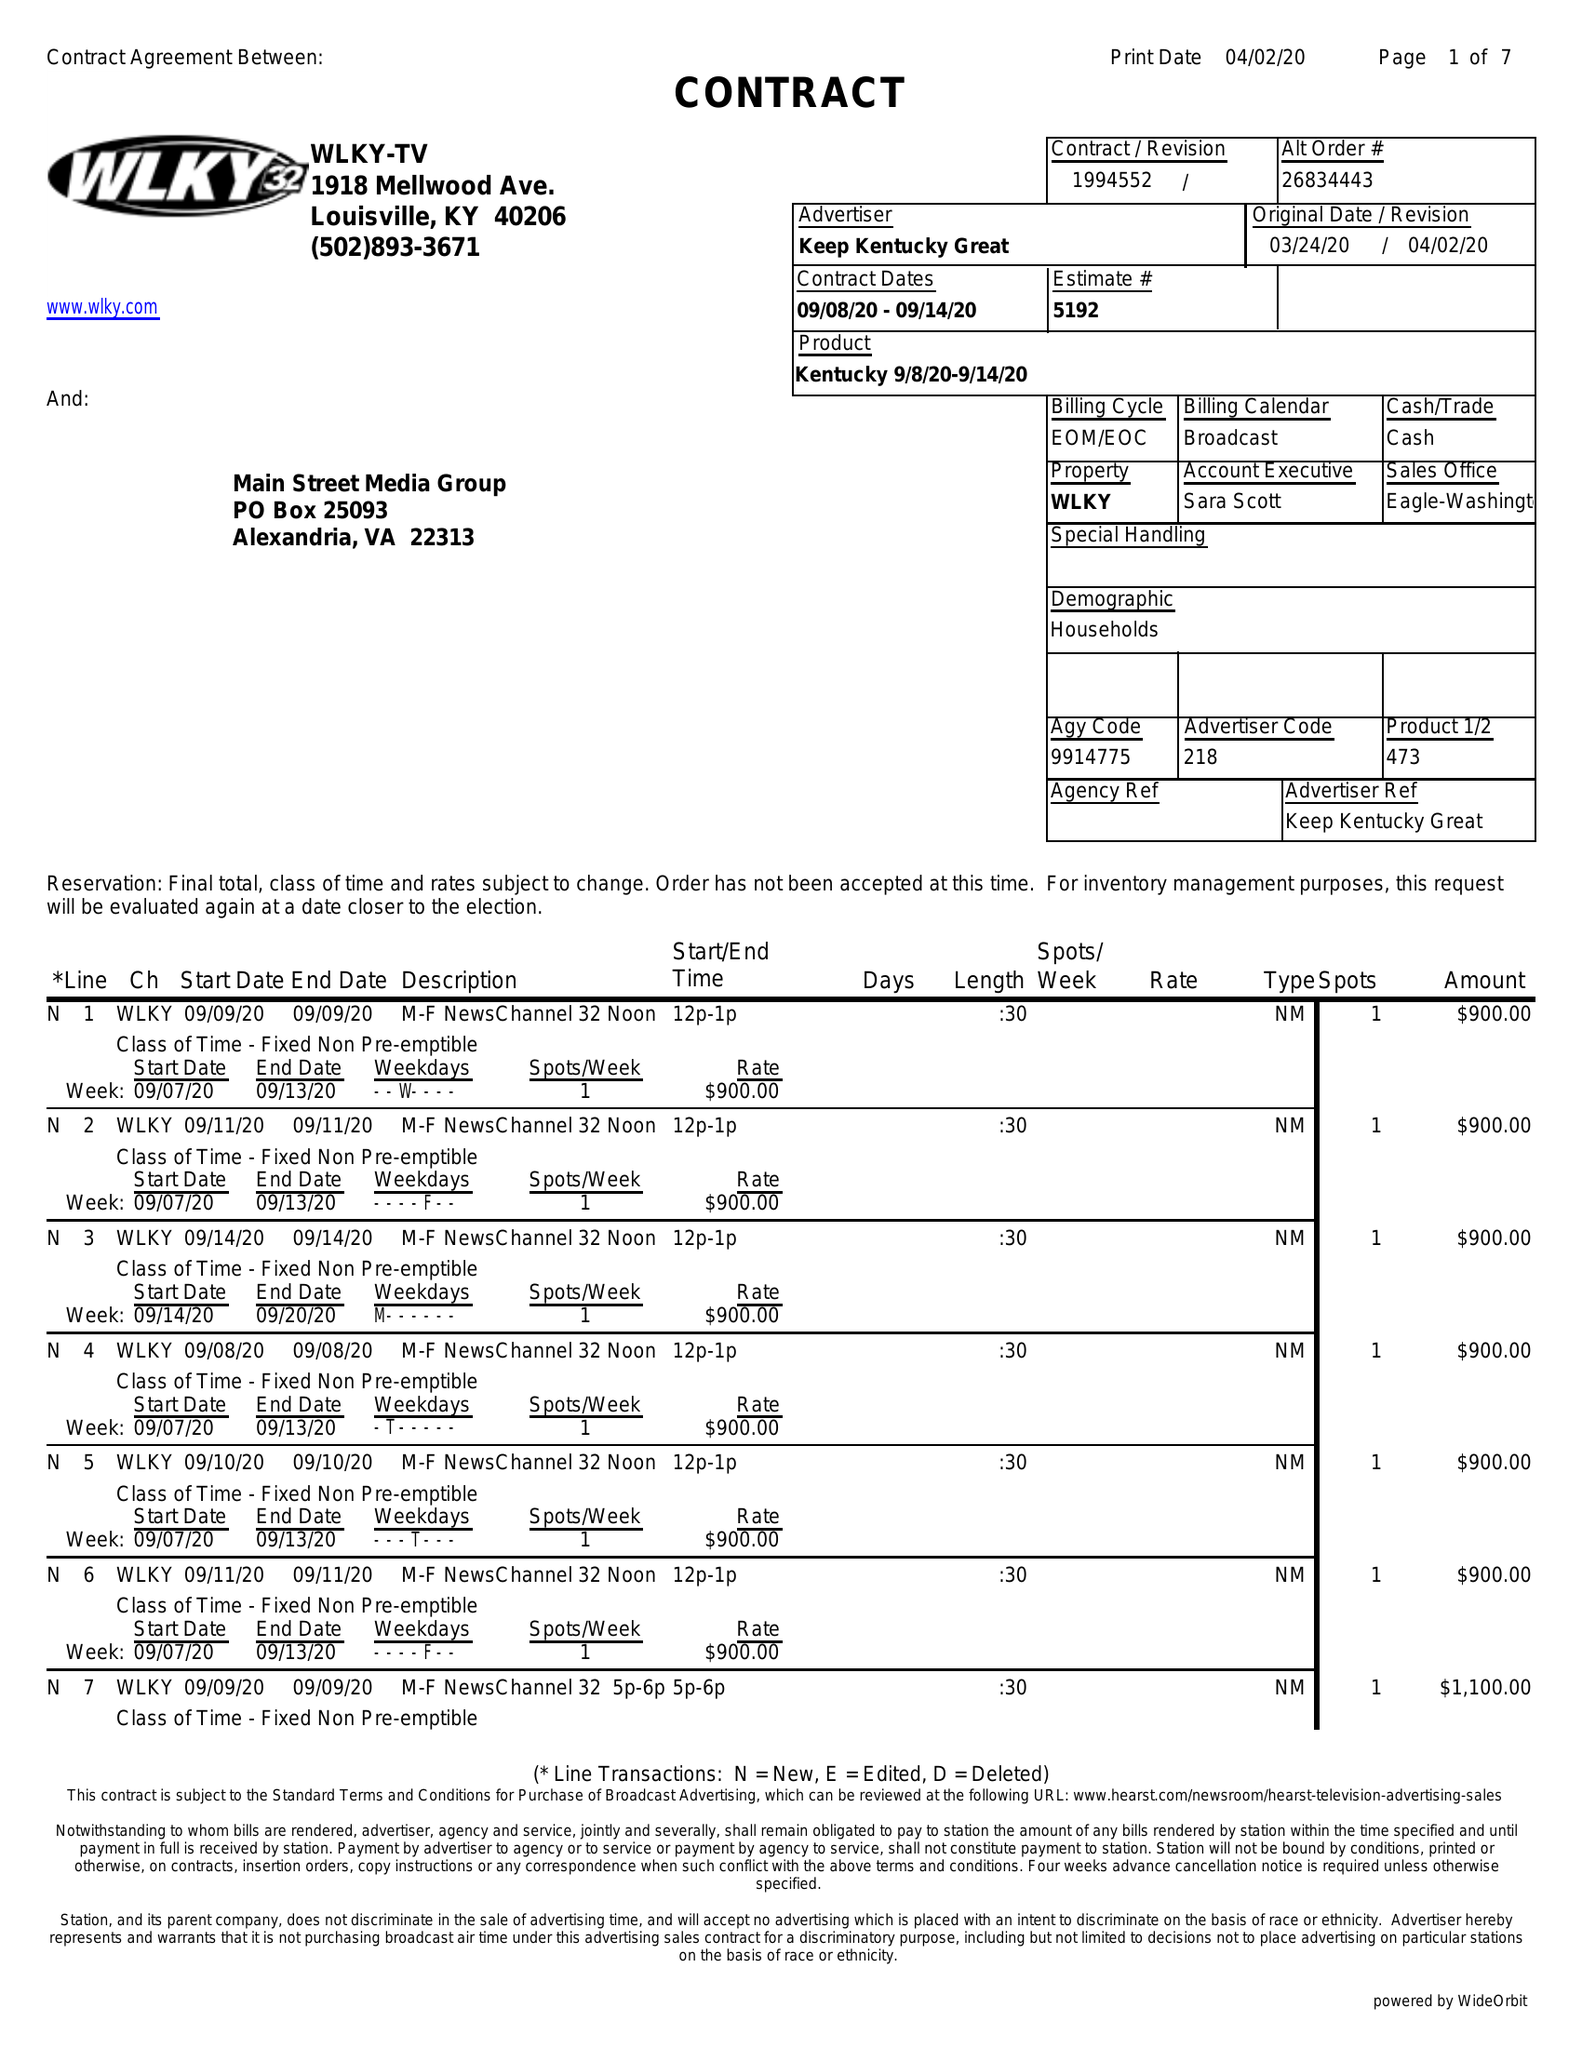What is the value for the advertiser?
Answer the question using a single word or phrase. KEEP KENTUCKY GREAT 